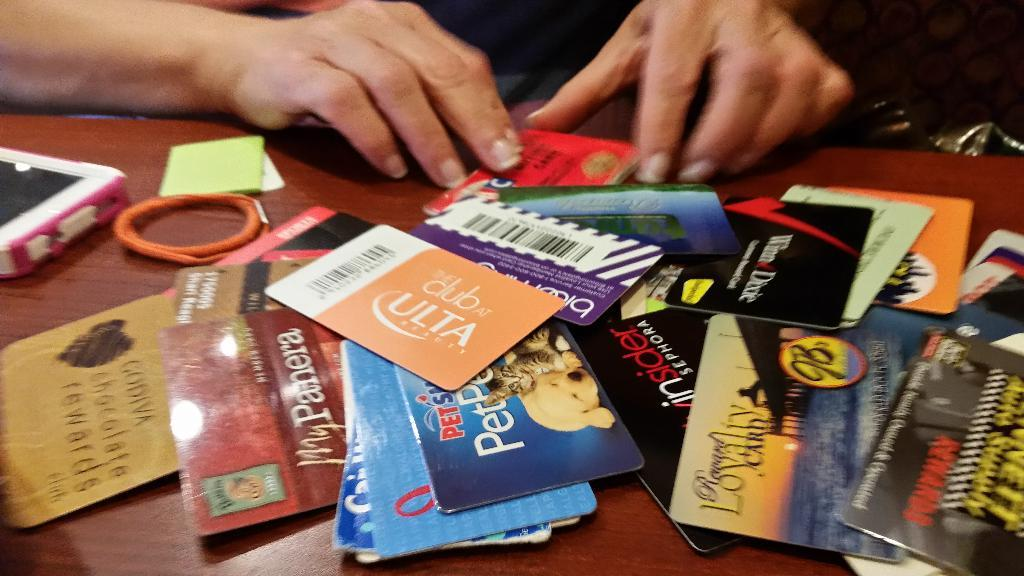<image>
Render a clear and concise summary of the photo. A PetSmart giftcard is buried among a bunch of other giftcards. 